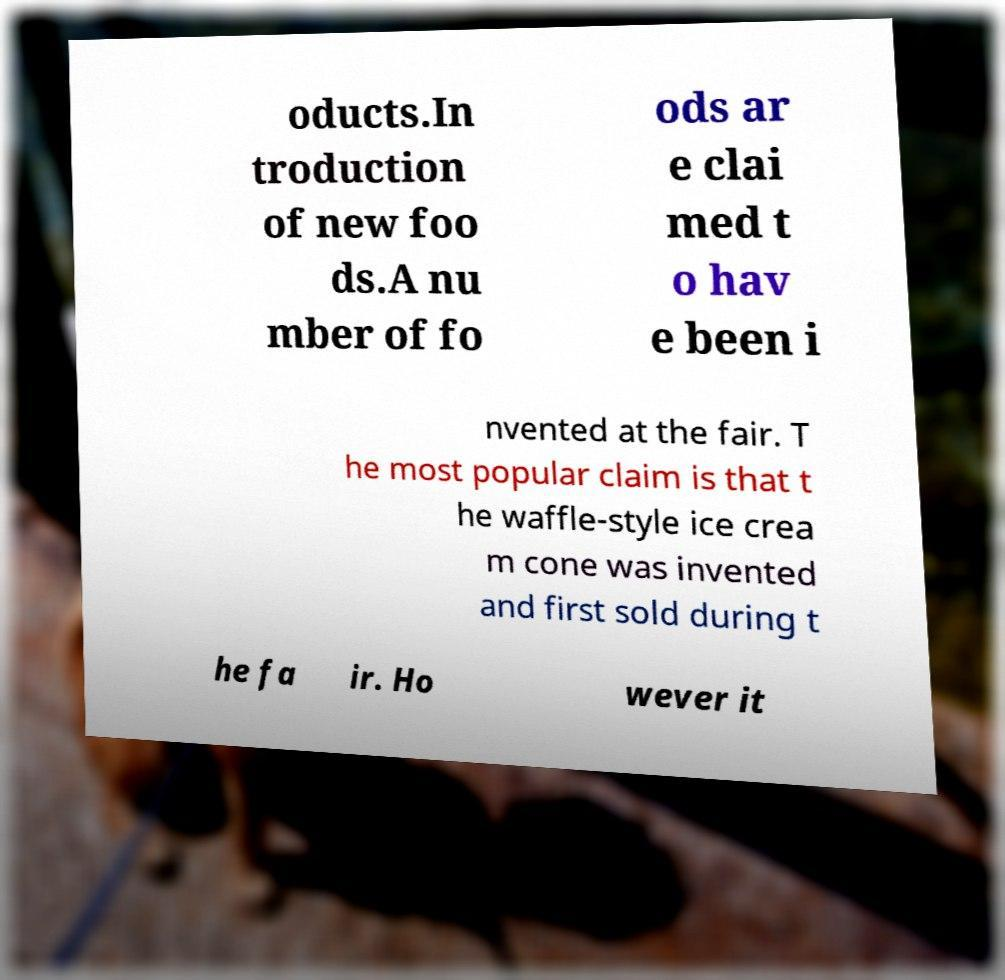For documentation purposes, I need the text within this image transcribed. Could you provide that? oducts.In troduction of new foo ds.A nu mber of fo ods ar e clai med t o hav e been i nvented at the fair. T he most popular claim is that t he waffle-style ice crea m cone was invented and first sold during t he fa ir. Ho wever it 